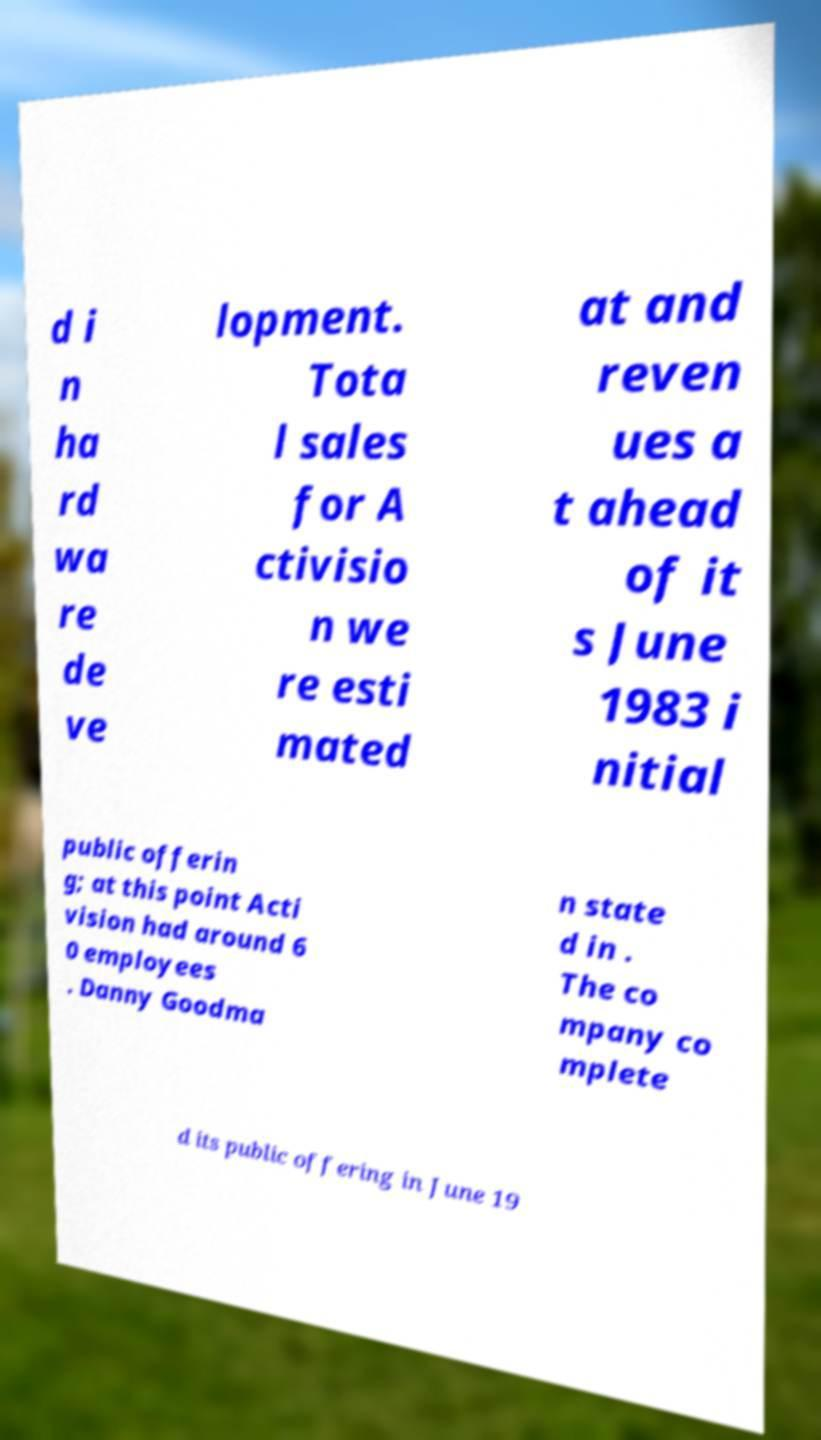Can you accurately transcribe the text from the provided image for me? d i n ha rd wa re de ve lopment. Tota l sales for A ctivisio n we re esti mated at and reven ues a t ahead of it s June 1983 i nitial public offerin g; at this point Acti vision had around 6 0 employees . Danny Goodma n state d in . The co mpany co mplete d its public offering in June 19 